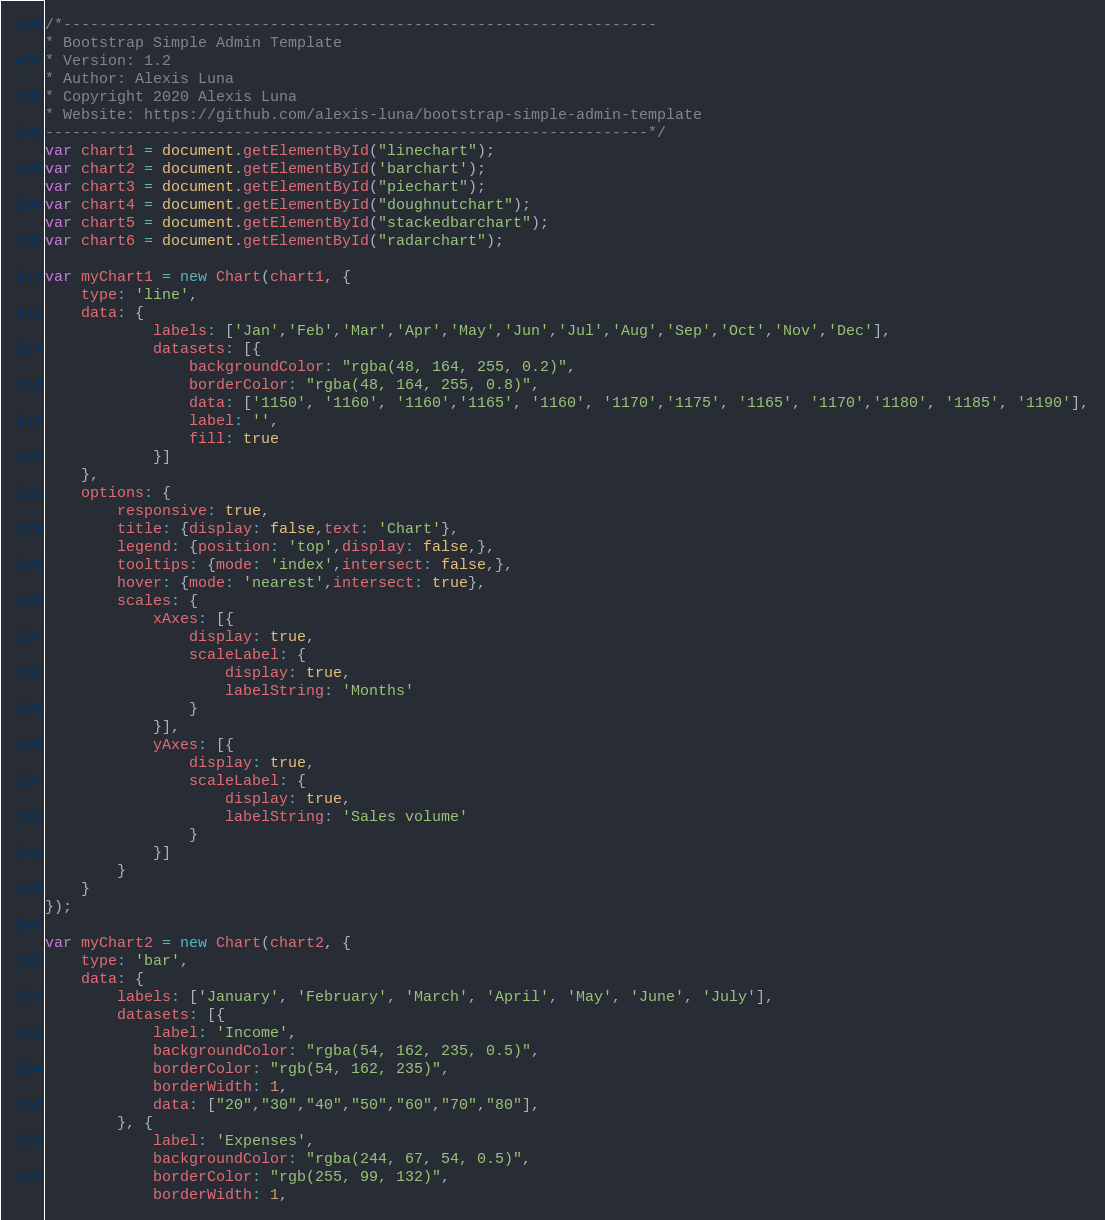<code> <loc_0><loc_0><loc_500><loc_500><_JavaScript_>/*------------------------------------------------------------------
* Bootstrap Simple Admin Template
* Version: 1.2
* Author: Alexis Luna
* Copyright 2020 Alexis Luna
* Website: https://github.com/alexis-luna/bootstrap-simple-admin-template
-------------------------------------------------------------------*/
var chart1 = document.getElementById("linechart");
var chart2 = document.getElementById('barchart');
var chart3 = document.getElementById("piechart");
var chart4 = document.getElementById("doughnutchart");
var chart5 = document.getElementById("stackedbarchart");
var chart6 = document.getElementById("radarchart");

var myChart1 = new Chart(chart1, {
    type: 'line',
    data: {
            labels: ['Jan','Feb','Mar','Apr','May','Jun','Jul','Aug','Sep','Oct','Nov','Dec'],
            datasets: [{
                backgroundColor: "rgba(48, 164, 255, 0.2)",
                borderColor: "rgba(48, 164, 255, 0.8)",
                data: ['1150', '1160', '1160','1165', '1160', '1170','1175', '1165', '1170','1180', '1185', '1190'],
                label: '',
                fill: true
            }]
    },
    options: {
        responsive: true,
        title: {display: false,text: 'Chart'},
        legend: {position: 'top',display: false,},
        tooltips: {mode: 'index',intersect: false,},
        hover: {mode: 'nearest',intersect: true},
        scales: {
            xAxes: [{
                display: true,
                scaleLabel: {
                    display: true,
                    labelString: 'Months'
                }
            }],
            yAxes: [{
                display: true,
                scaleLabel: {
                    display: true,
                    labelString: 'Sales volume'
                }
            }]
        }
    }
});

var myChart2 = new Chart(chart2, {
    type: 'bar',
    data: {
        labels: ['January', 'February', 'March', 'April', 'May', 'June', 'July'],
        datasets: [{
            label: 'Income',
            backgroundColor: "rgba(54, 162, 235, 0.5)",
            borderColor: "rgb(54, 162, 235)",
            borderWidth: 1,
            data: ["20","30","40","50","60","70","80"],
        }, {
            label: 'Expenses',
            backgroundColor: "rgba(244, 67, 54, 0.5)",
            borderColor: "rgb(255, 99, 132)",
            borderWidth: 1,</code> 